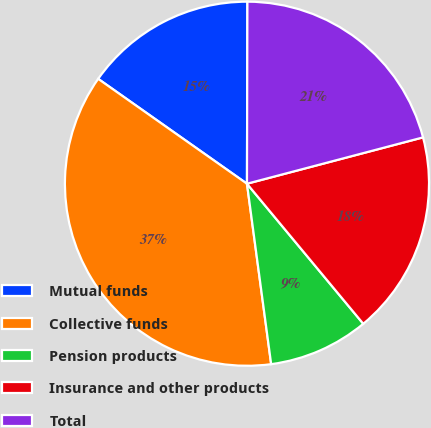<chart> <loc_0><loc_0><loc_500><loc_500><pie_chart><fcel>Mutual funds<fcel>Collective funds<fcel>Pension products<fcel>Insurance and other products<fcel>Total<nl><fcel>15.27%<fcel>36.9%<fcel>8.91%<fcel>18.07%<fcel>20.87%<nl></chart> 